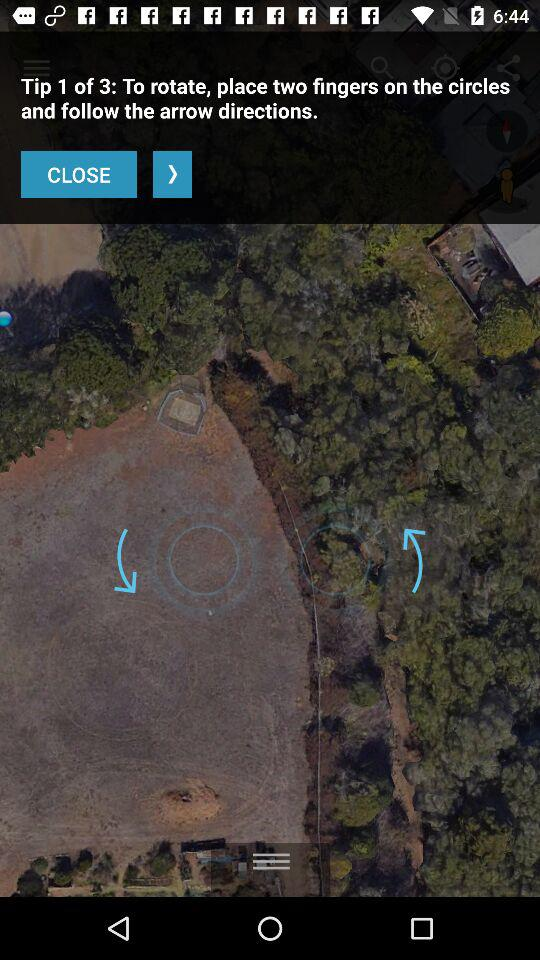What is the current tip number? The current tip number is 1. 